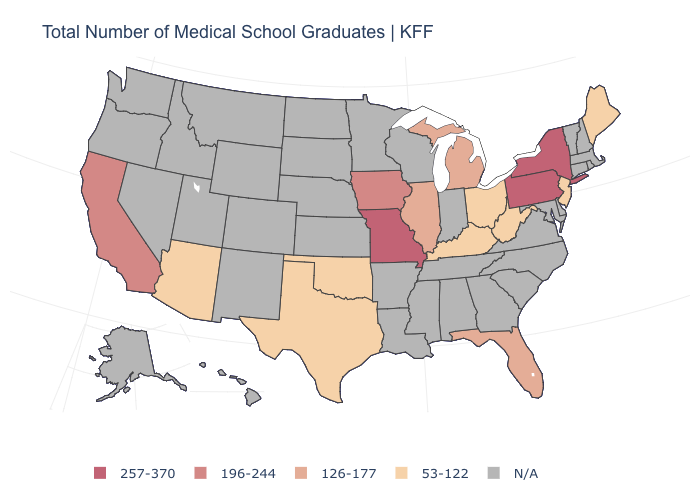Among the states that border West Virginia , does Kentucky have the lowest value?
Quick response, please. Yes. Name the states that have a value in the range 257-370?
Be succinct. Missouri, New York, Pennsylvania. Name the states that have a value in the range 126-177?
Concise answer only. Florida, Illinois, Michigan. What is the value of Connecticut?
Short answer required. N/A. Which states have the lowest value in the USA?
Give a very brief answer. Arizona, Kentucky, Maine, New Jersey, Ohio, Oklahoma, Texas, West Virginia. Name the states that have a value in the range 53-122?
Give a very brief answer. Arizona, Kentucky, Maine, New Jersey, Ohio, Oklahoma, Texas, West Virginia. Does Arizona have the lowest value in the USA?
Concise answer only. Yes. Does Ohio have the lowest value in the MidWest?
Answer briefly. Yes. What is the lowest value in the West?
Short answer required. 53-122. Among the states that border New York , does New Jersey have the highest value?
Short answer required. No. Among the states that border Virginia , which have the highest value?
Be succinct. Kentucky, West Virginia. Does California have the lowest value in the West?
Short answer required. No. Name the states that have a value in the range 126-177?
Concise answer only. Florida, Illinois, Michigan. Does the map have missing data?
Quick response, please. Yes. 